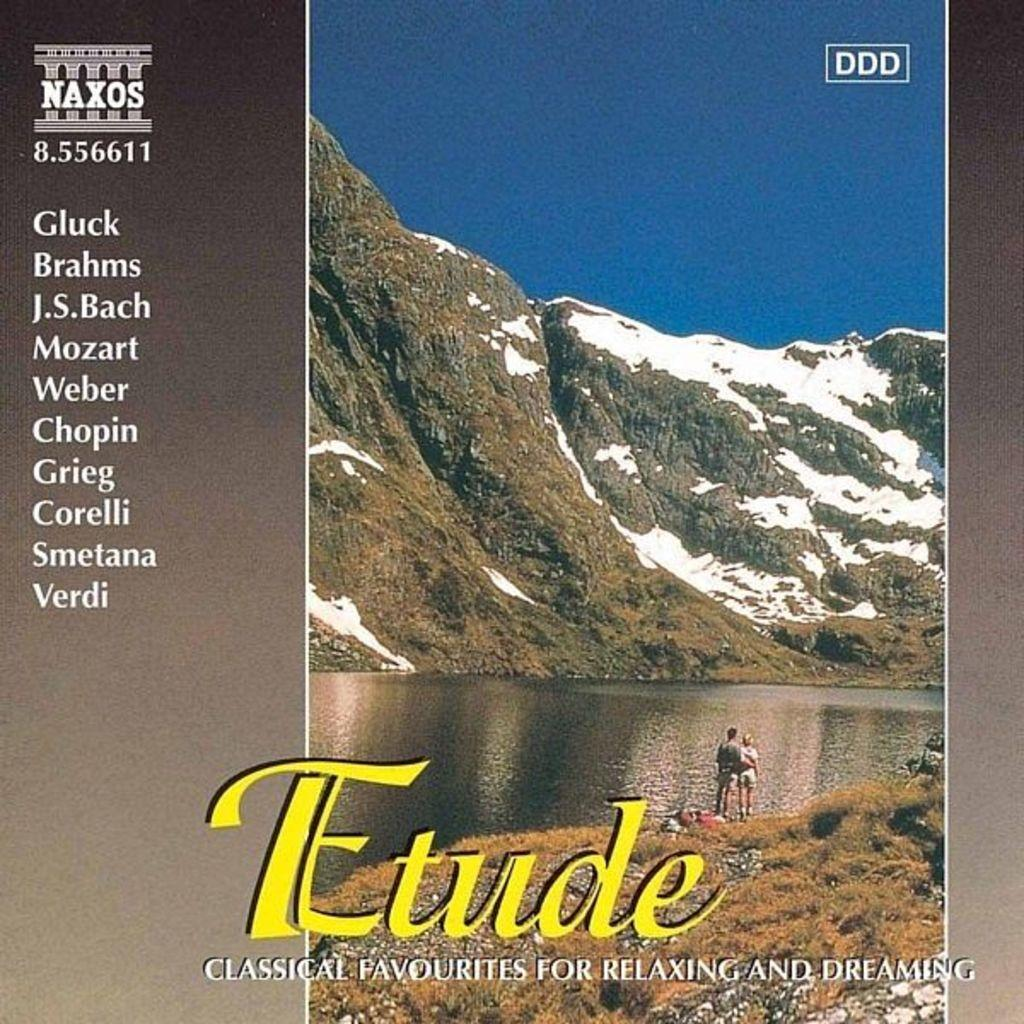<image>
Present a compact description of the photo's key features. album of classical favorites that shows a couple standing next to a river looking at snowy mountains 